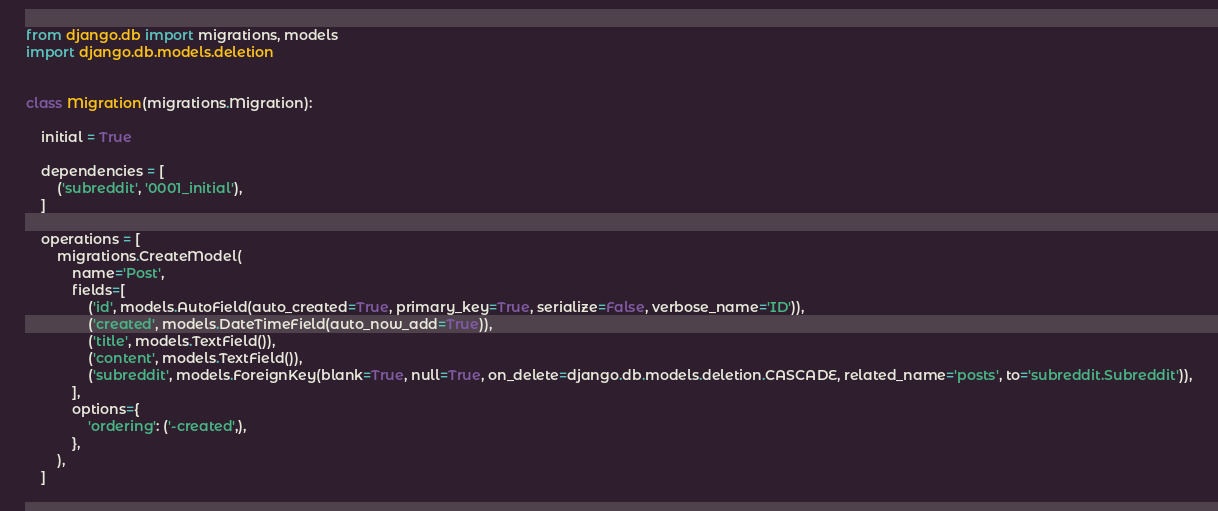<code> <loc_0><loc_0><loc_500><loc_500><_Python_>
from django.db import migrations, models
import django.db.models.deletion


class Migration(migrations.Migration):

    initial = True

    dependencies = [
        ('subreddit', '0001_initial'),
    ]

    operations = [
        migrations.CreateModel(
            name='Post',
            fields=[
                ('id', models.AutoField(auto_created=True, primary_key=True, serialize=False, verbose_name='ID')),
                ('created', models.DateTimeField(auto_now_add=True)),
                ('title', models.TextField()),
                ('content', models.TextField()),
                ('subreddit', models.ForeignKey(blank=True, null=True, on_delete=django.db.models.deletion.CASCADE, related_name='posts', to='subreddit.Subreddit')),
            ],
            options={
                'ordering': ('-created',),
            },
        ),
    ]
</code> 